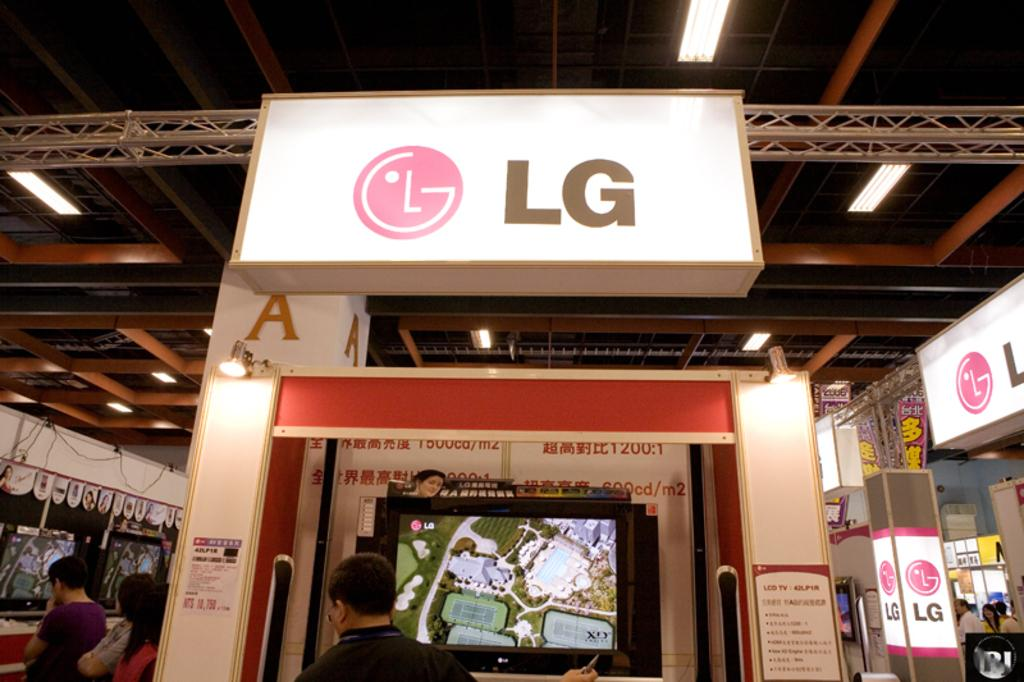Who or what can be seen in the image? There are people in the image. What objects are present that display information or images? Screens, name boards, and posters are visible in the image. What can be used to provide illumination in the image? Lights are present in the image. What type of structural elements can be seen in the image? Rods are visible in the image. Are there any other unspecified objects in the image? Yes, there are some unspecified objects in the image. How many baseballs can be seen in the image? There is no mention of baseballs in the image, so it is not possible to determine how many are present. 